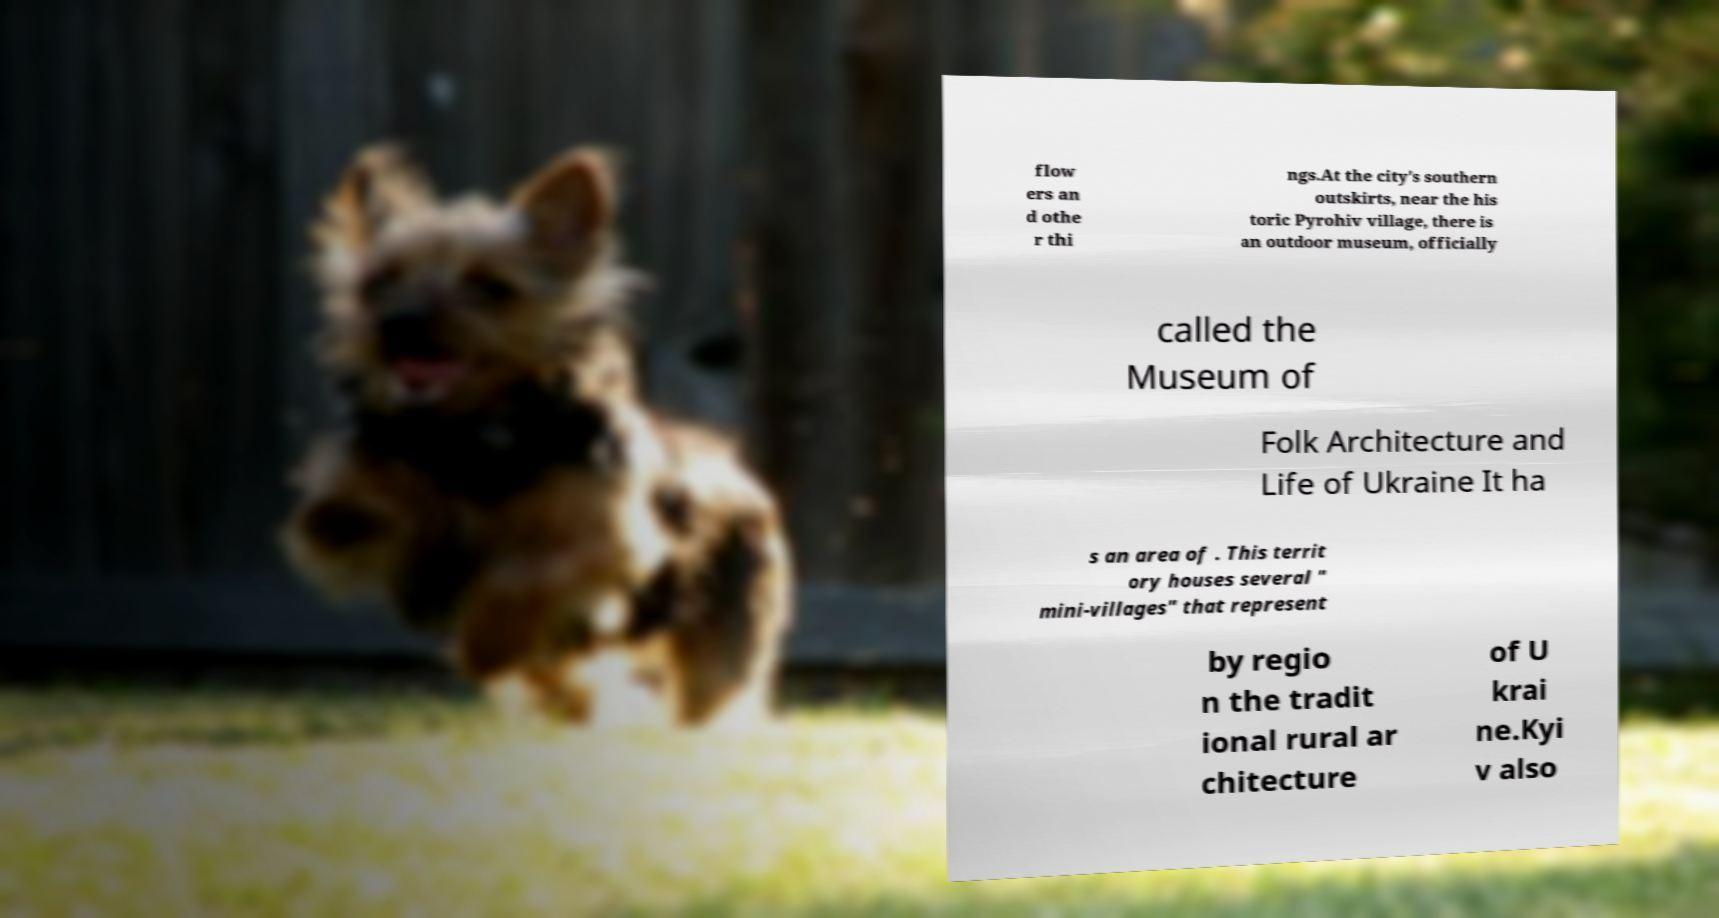Could you assist in decoding the text presented in this image and type it out clearly? flow ers an d othe r thi ngs.At the city's southern outskirts, near the his toric Pyrohiv village, there is an outdoor museum, officially called the Museum of Folk Architecture and Life of Ukraine It ha s an area of . This territ ory houses several " mini-villages" that represent by regio n the tradit ional rural ar chitecture of U krai ne.Kyi v also 